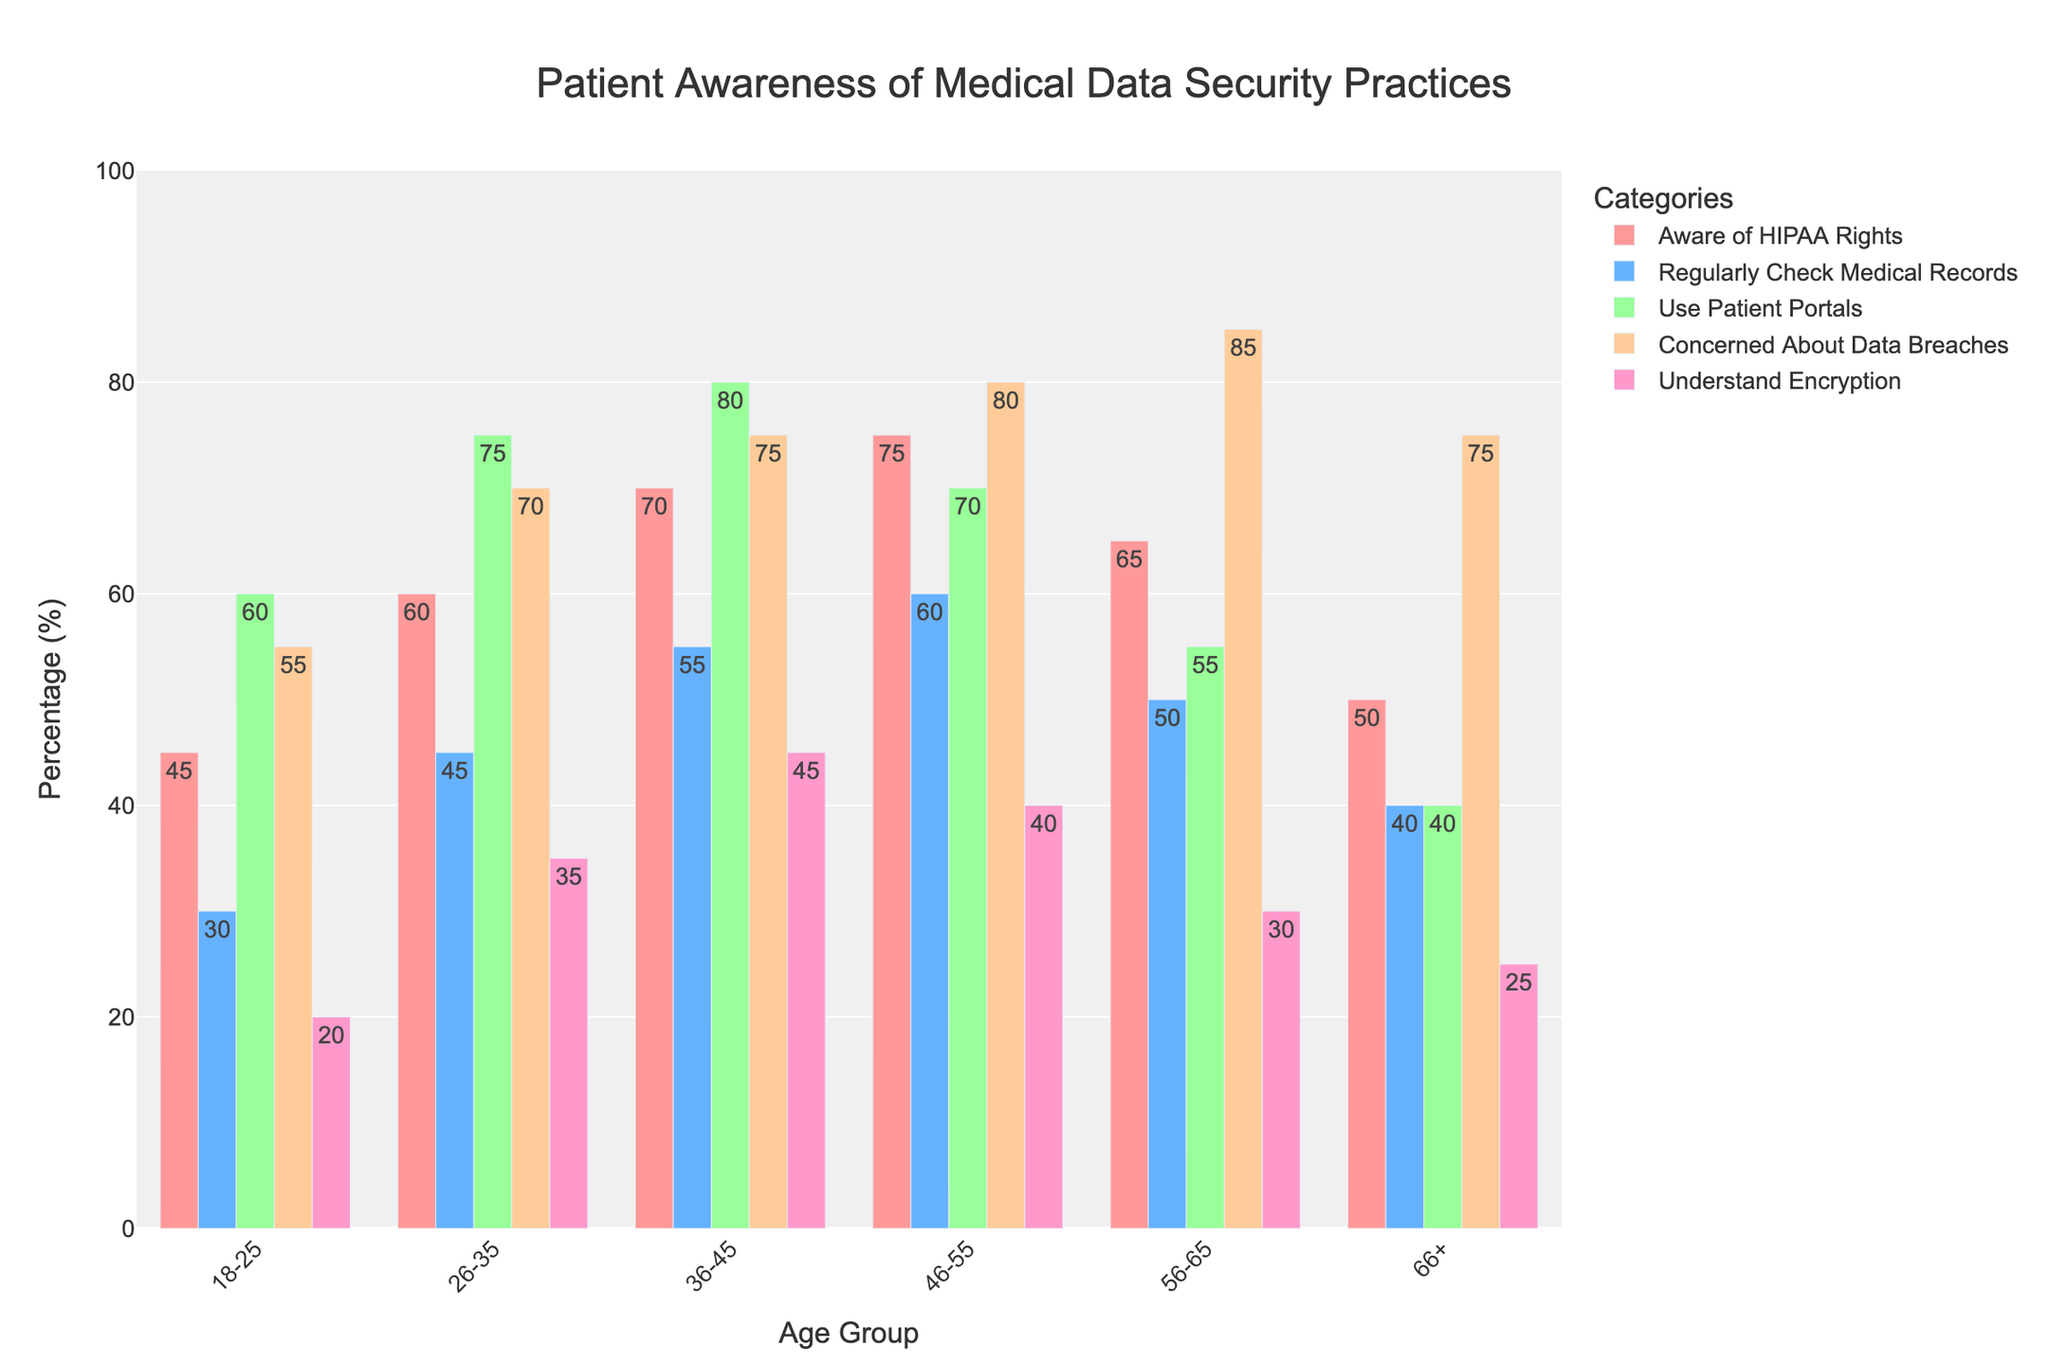Which age group has the highest percentage of patients who regularly check their medical records? The bar for "Regularly Check Medical Records" shows the highest peak at the age group 46-55.
Answer: 46-55 How does the percentage of patients concerned about data breaches change from the 18-25 age group to the 56-65 age group? The percentage increases from 55% in the 18-25 age group to 85% in the 56-65 age group. The change is 85% - 55% = 30%.
Answer: It increases by 30% Compare the percentage of patients in the 36-45 and 66+ age groups who use patient portals. The 36-45 age group has 80% while the 66+ age group has 40%. The difference is 80% - 40% = 40%.
Answer: 36-45 age group has 40% more Which category has the least patient awareness level across all age groups? By scanning the bars, the category "Understand Encryption" consistently has lower values compared to other categories across all age groups.
Answer: Understand Encryption What's the average percentage of patients in the 26-35 age group who are either aware of HIPAA rights or understand encryption? The values are 60% for "Aware of HIPAA Rights" and 35% for "Understand Encryption". Average = (60 + 35) / 2 = 47.5%.
Answer: 47.5% Is the percentage of patients aged 56-65 who are concerned about data breaches higher than those aged 18-25 who use patient portals? For the 56-65 age group, the percentage concerned about data breaches is 85%, and for the 18-25 age group using patient portals, it is 60%. 85% > 60%.
Answer: Yes Which age group shows the highest understanding of encryption and how much is it? The bar for "Understand Encryption" is highest for the 36-45 age group at 45%.
Answer: 36-45; 45% What is the total percentage of patients aged 66+ who are aware of HIPAA rights, regularly check their medical records, and use patient portals? Sum the values: 50% (Aware of HIPAA Rights) + 40% (Regularly Check Medical Records) + 40% (Use Patient Portals) = 130%.
Answer: 130% Compare the difference in the percentage of patients concerned about data breaches between the age groups 36-45 and 46-55. The 36-45 age group has 75%, and the 46-55 age group has 80%. Difference = 80% - 75% = 5%.
Answer: 5% What is the median percentage of those aged 26-35 who are aware of HIPAA rights, regularly check medical records, and use patient portals? Arrange the values: 45% (Regularly Check Medical Records), 60% (Aware of HIPAA Rights), 75% (Use Patient Portals). The median is the middle value: 60%.
Answer: 60% 